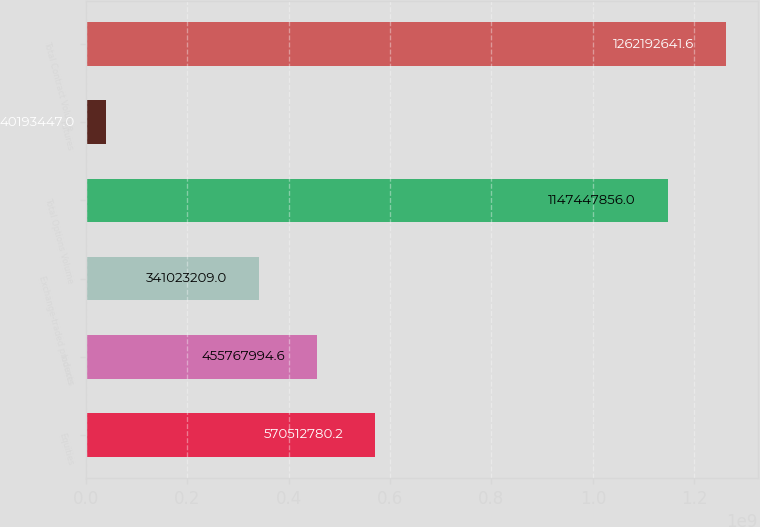Convert chart. <chart><loc_0><loc_0><loc_500><loc_500><bar_chart><fcel>Equities<fcel>Indexes<fcel>Exchange-traded products<fcel>Total Options Volume<fcel>Futures<fcel>Total Contract Volume<nl><fcel>5.70513e+08<fcel>4.55768e+08<fcel>3.41023e+08<fcel>1.14745e+09<fcel>4.01934e+07<fcel>1.26219e+09<nl></chart> 